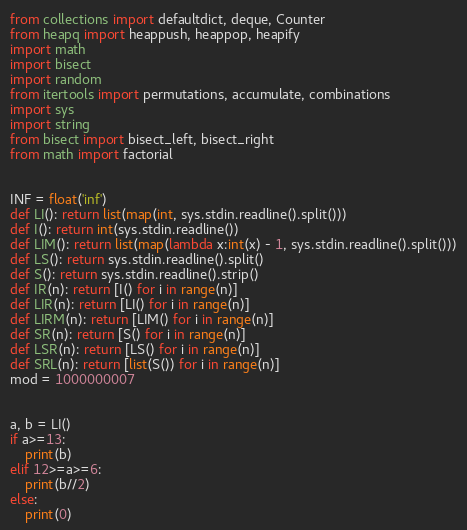Convert code to text. <code><loc_0><loc_0><loc_500><loc_500><_Python_>from collections import defaultdict, deque, Counter
from heapq import heappush, heappop, heapify
import math
import bisect
import random
from itertools import permutations, accumulate, combinations
import sys
import string
from bisect import bisect_left, bisect_right
from math import factorial


INF = float('inf')
def LI(): return list(map(int, sys.stdin.readline().split()))
def I(): return int(sys.stdin.readline())
def LIM(): return list(map(lambda x:int(x) - 1, sys.stdin.readline().split()))
def LS(): return sys.stdin.readline().split()
def S(): return sys.stdin.readline().strip()
def IR(n): return [I() for i in range(n)]
def LIR(n): return [LI() for i in range(n)]
def LIRM(n): return [LIM() for i in range(n)]
def SR(n): return [S() for i in range(n)]
def LSR(n): return [LS() for i in range(n)]
def SRL(n): return [list(S()) for i in range(n)]
mod = 1000000007


a, b = LI()
if a>=13:
    print(b)
elif 12>=a>=6:
    print(b//2)
else:
    print(0)</code> 